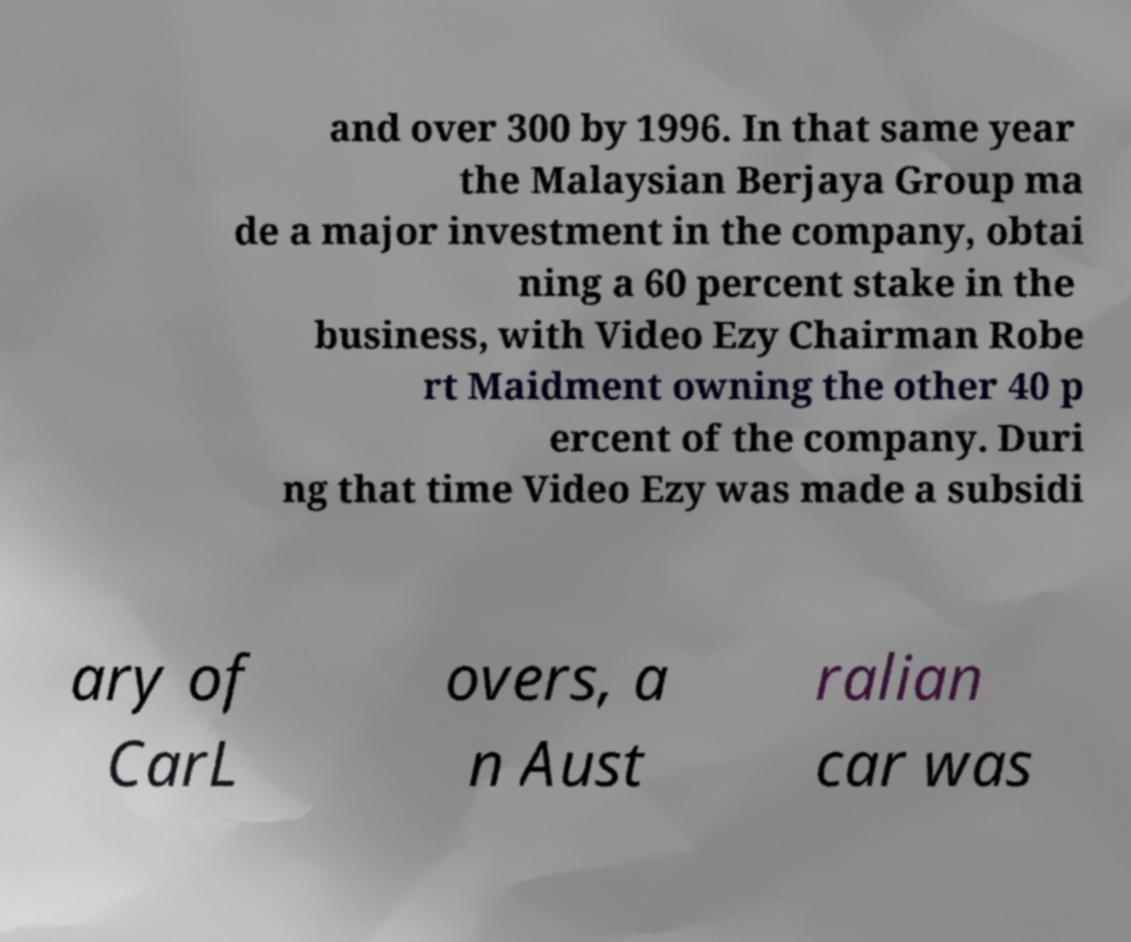Please read and relay the text visible in this image. What does it say? and over 300 by 1996. In that same year the Malaysian Berjaya Group ma de a major investment in the company, obtai ning a 60 percent stake in the business, with Video Ezy Chairman Robe rt Maidment owning the other 40 p ercent of the company. Duri ng that time Video Ezy was made a subsidi ary of CarL overs, a n Aust ralian car was 